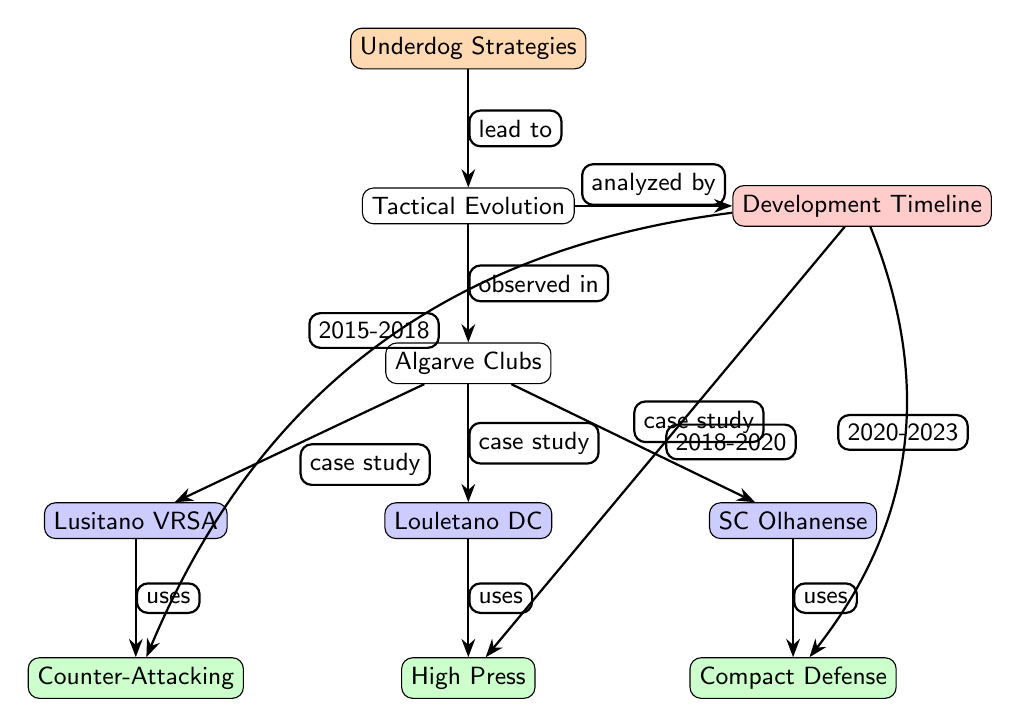What is the main topic of the diagram? The diagram's main topic, highlighted at the top node, is "Underdog Strategies," indicating that the focus is on strategies employed by clubs that are typically viewed as underdogs in football.
Answer: Underdog Strategies How many clubs are represented in the diagram? The diagram includes three clubs as noted in the nodes under "Algarve Clubs": Lusitano VRSA, Louletano DC, and SC Olhanense, indicating a comparison of their tactical approaches.
Answer: Three What tactical approach does Lusitano VRSA utilize? Directly below the Lusitano VRSA node, it states "Counter-Attacking" as the tactic used by this club, showing their strategic focus in matches.
Answer: Counter-Attacking Which tactical approach was observed for SC Olhanense? The node below SC Olhanense indicates "Compact Defense" as the tactic used, which signifies their defensive strategy while playing matches.
Answer: Compact Defense Which years mark the timeline for the tactical evolution analysis? The timeline node connects to various tactics with specific time frames; the years covered range from 2015 to 2023 across the tactics employed, showing how strategies have evolved over time.
Answer: 2015-2023 What tactical approach does Louletano DC employ according to the diagram? Positioned below Louletano DC, the diagram specifies "High Press" as the strategy this club uses, reflecting their aggressive approach to opponent possession.
Answer: High Press Which club employs the "High Press" tactic? The diagram explicitly shows that Louletano DC is linked to the "High Press" tactic, indicating that this club adopts this strategy during its games.
Answer: Louletano DC How many tactics are illustrated in the diagram? There are three distinct tactics identified beneath their respective clubs: Counter-Attacking, High Press, and Compact Defense, highlighting the diversity of approach among the clubs.
Answer: Three What type of relationships are indicated by the arrows in the diagram? The arrows represent causal relationships between nodes, such as "lead to," "observed in," and "uses," demonstrating how the concepts are connected logically in the context of underdog strategies.
Answer: Causal relationships 